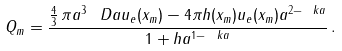Convert formula to latex. <formula><loc_0><loc_0><loc_500><loc_500>Q _ { m } = \frac { \frac { 4 } { 3 } \, \pi a ^ { 3 } \, \ D a u _ { e } ( x _ { m } ) - 4 \pi h ( x _ { m } ) u _ { e } ( x _ { m } ) a ^ { 2 - \ k a } } { 1 + h a ^ { 1 - \ k a } } \, .</formula> 